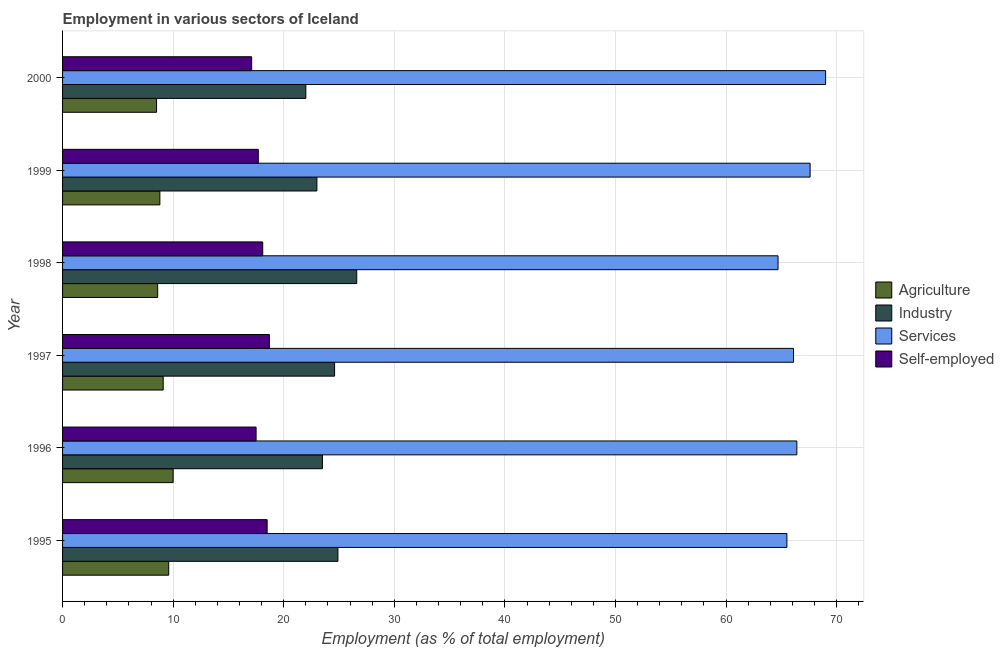Are the number of bars per tick equal to the number of legend labels?
Your response must be concise. Yes. What is the percentage of self employed workers in 2000?
Ensure brevity in your answer.  17.1. Across all years, what is the maximum percentage of workers in industry?
Your response must be concise. 26.6. Across all years, what is the minimum percentage of self employed workers?
Offer a terse response. 17.1. In which year was the percentage of workers in services minimum?
Ensure brevity in your answer.  1998. What is the total percentage of workers in agriculture in the graph?
Give a very brief answer. 54.6. What is the difference between the percentage of workers in services in 1996 and that in 1998?
Offer a terse response. 1.7. What is the difference between the percentage of workers in services in 1995 and the percentage of workers in agriculture in 1996?
Make the answer very short. 55.5. What is the average percentage of workers in services per year?
Provide a short and direct response. 66.55. Is the difference between the percentage of workers in industry in 1996 and 1999 greater than the difference between the percentage of workers in services in 1996 and 1999?
Offer a very short reply. Yes. What is the difference between the highest and the lowest percentage of workers in services?
Make the answer very short. 4.3. In how many years, is the percentage of workers in industry greater than the average percentage of workers in industry taken over all years?
Keep it short and to the point. 3. Is the sum of the percentage of self employed workers in 1996 and 1999 greater than the maximum percentage of workers in agriculture across all years?
Your answer should be compact. Yes. Is it the case that in every year, the sum of the percentage of workers in services and percentage of workers in industry is greater than the sum of percentage of self employed workers and percentage of workers in agriculture?
Offer a very short reply. No. What does the 1st bar from the top in 1997 represents?
Your answer should be very brief. Self-employed. What does the 3rd bar from the bottom in 1998 represents?
Your response must be concise. Services. Is it the case that in every year, the sum of the percentage of workers in agriculture and percentage of workers in industry is greater than the percentage of workers in services?
Your response must be concise. No. Are all the bars in the graph horizontal?
Give a very brief answer. Yes. How many years are there in the graph?
Your answer should be compact. 6. Are the values on the major ticks of X-axis written in scientific E-notation?
Offer a terse response. No. Does the graph contain any zero values?
Provide a succinct answer. No. How many legend labels are there?
Keep it short and to the point. 4. How are the legend labels stacked?
Make the answer very short. Vertical. What is the title of the graph?
Make the answer very short. Employment in various sectors of Iceland. What is the label or title of the X-axis?
Offer a terse response. Employment (as % of total employment). What is the Employment (as % of total employment) of Agriculture in 1995?
Your answer should be very brief. 9.6. What is the Employment (as % of total employment) of Industry in 1995?
Provide a succinct answer. 24.9. What is the Employment (as % of total employment) of Services in 1995?
Give a very brief answer. 65.5. What is the Employment (as % of total employment) of Self-employed in 1995?
Provide a short and direct response. 18.5. What is the Employment (as % of total employment) in Agriculture in 1996?
Your response must be concise. 10. What is the Employment (as % of total employment) of Services in 1996?
Offer a very short reply. 66.4. What is the Employment (as % of total employment) in Self-employed in 1996?
Your response must be concise. 17.5. What is the Employment (as % of total employment) of Agriculture in 1997?
Your answer should be very brief. 9.1. What is the Employment (as % of total employment) of Industry in 1997?
Offer a very short reply. 24.6. What is the Employment (as % of total employment) of Services in 1997?
Keep it short and to the point. 66.1. What is the Employment (as % of total employment) in Self-employed in 1997?
Your answer should be very brief. 18.7. What is the Employment (as % of total employment) in Agriculture in 1998?
Offer a terse response. 8.6. What is the Employment (as % of total employment) in Industry in 1998?
Provide a short and direct response. 26.6. What is the Employment (as % of total employment) in Services in 1998?
Keep it short and to the point. 64.7. What is the Employment (as % of total employment) of Self-employed in 1998?
Make the answer very short. 18.1. What is the Employment (as % of total employment) of Agriculture in 1999?
Keep it short and to the point. 8.8. What is the Employment (as % of total employment) of Industry in 1999?
Make the answer very short. 23. What is the Employment (as % of total employment) in Services in 1999?
Your answer should be compact. 67.6. What is the Employment (as % of total employment) in Self-employed in 1999?
Make the answer very short. 17.7. What is the Employment (as % of total employment) of Services in 2000?
Make the answer very short. 69. What is the Employment (as % of total employment) of Self-employed in 2000?
Ensure brevity in your answer.  17.1. Across all years, what is the maximum Employment (as % of total employment) of Industry?
Your answer should be very brief. 26.6. Across all years, what is the maximum Employment (as % of total employment) in Self-employed?
Make the answer very short. 18.7. Across all years, what is the minimum Employment (as % of total employment) in Agriculture?
Ensure brevity in your answer.  8.5. Across all years, what is the minimum Employment (as % of total employment) of Services?
Keep it short and to the point. 64.7. Across all years, what is the minimum Employment (as % of total employment) of Self-employed?
Your response must be concise. 17.1. What is the total Employment (as % of total employment) of Agriculture in the graph?
Give a very brief answer. 54.6. What is the total Employment (as % of total employment) of Industry in the graph?
Ensure brevity in your answer.  144.6. What is the total Employment (as % of total employment) of Services in the graph?
Ensure brevity in your answer.  399.3. What is the total Employment (as % of total employment) in Self-employed in the graph?
Your answer should be compact. 107.6. What is the difference between the Employment (as % of total employment) of Services in 1995 and that in 1996?
Provide a short and direct response. -0.9. What is the difference between the Employment (as % of total employment) in Industry in 1995 and that in 1997?
Your answer should be compact. 0.3. What is the difference between the Employment (as % of total employment) in Services in 1995 and that in 1997?
Give a very brief answer. -0.6. What is the difference between the Employment (as % of total employment) of Industry in 1995 and that in 1998?
Give a very brief answer. -1.7. What is the difference between the Employment (as % of total employment) in Services in 1995 and that in 1998?
Make the answer very short. 0.8. What is the difference between the Employment (as % of total employment) of Agriculture in 1995 and that in 1999?
Offer a terse response. 0.8. What is the difference between the Employment (as % of total employment) in Industry in 1995 and that in 1999?
Your answer should be compact. 1.9. What is the difference between the Employment (as % of total employment) in Agriculture in 1995 and that in 2000?
Make the answer very short. 1.1. What is the difference between the Employment (as % of total employment) of Industry in 1995 and that in 2000?
Give a very brief answer. 2.9. What is the difference between the Employment (as % of total employment) of Self-employed in 1995 and that in 2000?
Your response must be concise. 1.4. What is the difference between the Employment (as % of total employment) of Agriculture in 1996 and that in 1997?
Offer a very short reply. 0.9. What is the difference between the Employment (as % of total employment) of Industry in 1996 and that in 1997?
Your answer should be very brief. -1.1. What is the difference between the Employment (as % of total employment) of Self-employed in 1996 and that in 1997?
Provide a succinct answer. -1.2. What is the difference between the Employment (as % of total employment) of Agriculture in 1996 and that in 1998?
Your answer should be compact. 1.4. What is the difference between the Employment (as % of total employment) in Self-employed in 1996 and that in 1998?
Offer a terse response. -0.6. What is the difference between the Employment (as % of total employment) in Agriculture in 1996 and that in 1999?
Your response must be concise. 1.2. What is the difference between the Employment (as % of total employment) in Industry in 1996 and that in 1999?
Your response must be concise. 0.5. What is the difference between the Employment (as % of total employment) in Self-employed in 1996 and that in 1999?
Give a very brief answer. -0.2. What is the difference between the Employment (as % of total employment) of Services in 1996 and that in 2000?
Your answer should be very brief. -2.6. What is the difference between the Employment (as % of total employment) in Agriculture in 1997 and that in 1998?
Make the answer very short. 0.5. What is the difference between the Employment (as % of total employment) of Industry in 1997 and that in 1998?
Give a very brief answer. -2. What is the difference between the Employment (as % of total employment) of Agriculture in 1997 and that in 1999?
Give a very brief answer. 0.3. What is the difference between the Employment (as % of total employment) in Industry in 1997 and that in 1999?
Ensure brevity in your answer.  1.6. What is the difference between the Employment (as % of total employment) of Self-employed in 1997 and that in 1999?
Your answer should be compact. 1. What is the difference between the Employment (as % of total employment) in Agriculture in 1997 and that in 2000?
Ensure brevity in your answer.  0.6. What is the difference between the Employment (as % of total employment) in Industry in 1997 and that in 2000?
Give a very brief answer. 2.6. What is the difference between the Employment (as % of total employment) of Agriculture in 1998 and that in 1999?
Your answer should be compact. -0.2. What is the difference between the Employment (as % of total employment) in Services in 1998 and that in 1999?
Provide a short and direct response. -2.9. What is the difference between the Employment (as % of total employment) of Self-employed in 1998 and that in 1999?
Give a very brief answer. 0.4. What is the difference between the Employment (as % of total employment) of Industry in 1999 and that in 2000?
Your answer should be compact. 1. What is the difference between the Employment (as % of total employment) in Services in 1999 and that in 2000?
Keep it short and to the point. -1.4. What is the difference between the Employment (as % of total employment) in Self-employed in 1999 and that in 2000?
Your answer should be compact. 0.6. What is the difference between the Employment (as % of total employment) in Agriculture in 1995 and the Employment (as % of total employment) in Services in 1996?
Provide a succinct answer. -56.8. What is the difference between the Employment (as % of total employment) in Industry in 1995 and the Employment (as % of total employment) in Services in 1996?
Give a very brief answer. -41.5. What is the difference between the Employment (as % of total employment) of Industry in 1995 and the Employment (as % of total employment) of Self-employed in 1996?
Keep it short and to the point. 7.4. What is the difference between the Employment (as % of total employment) in Agriculture in 1995 and the Employment (as % of total employment) in Industry in 1997?
Your answer should be very brief. -15. What is the difference between the Employment (as % of total employment) in Agriculture in 1995 and the Employment (as % of total employment) in Services in 1997?
Keep it short and to the point. -56.5. What is the difference between the Employment (as % of total employment) of Industry in 1995 and the Employment (as % of total employment) of Services in 1997?
Offer a terse response. -41.2. What is the difference between the Employment (as % of total employment) in Industry in 1995 and the Employment (as % of total employment) in Self-employed in 1997?
Your response must be concise. 6.2. What is the difference between the Employment (as % of total employment) in Services in 1995 and the Employment (as % of total employment) in Self-employed in 1997?
Make the answer very short. 46.8. What is the difference between the Employment (as % of total employment) in Agriculture in 1995 and the Employment (as % of total employment) in Industry in 1998?
Provide a succinct answer. -17. What is the difference between the Employment (as % of total employment) of Agriculture in 1995 and the Employment (as % of total employment) of Services in 1998?
Offer a very short reply. -55.1. What is the difference between the Employment (as % of total employment) of Industry in 1995 and the Employment (as % of total employment) of Services in 1998?
Provide a short and direct response. -39.8. What is the difference between the Employment (as % of total employment) of Services in 1995 and the Employment (as % of total employment) of Self-employed in 1998?
Ensure brevity in your answer.  47.4. What is the difference between the Employment (as % of total employment) of Agriculture in 1995 and the Employment (as % of total employment) of Industry in 1999?
Your answer should be compact. -13.4. What is the difference between the Employment (as % of total employment) in Agriculture in 1995 and the Employment (as % of total employment) in Services in 1999?
Provide a short and direct response. -58. What is the difference between the Employment (as % of total employment) in Agriculture in 1995 and the Employment (as % of total employment) in Self-employed in 1999?
Your answer should be very brief. -8.1. What is the difference between the Employment (as % of total employment) in Industry in 1995 and the Employment (as % of total employment) in Services in 1999?
Your response must be concise. -42.7. What is the difference between the Employment (as % of total employment) of Industry in 1995 and the Employment (as % of total employment) of Self-employed in 1999?
Make the answer very short. 7.2. What is the difference between the Employment (as % of total employment) of Services in 1995 and the Employment (as % of total employment) of Self-employed in 1999?
Keep it short and to the point. 47.8. What is the difference between the Employment (as % of total employment) of Agriculture in 1995 and the Employment (as % of total employment) of Services in 2000?
Offer a very short reply. -59.4. What is the difference between the Employment (as % of total employment) in Industry in 1995 and the Employment (as % of total employment) in Services in 2000?
Give a very brief answer. -44.1. What is the difference between the Employment (as % of total employment) in Industry in 1995 and the Employment (as % of total employment) in Self-employed in 2000?
Your answer should be very brief. 7.8. What is the difference between the Employment (as % of total employment) of Services in 1995 and the Employment (as % of total employment) of Self-employed in 2000?
Keep it short and to the point. 48.4. What is the difference between the Employment (as % of total employment) in Agriculture in 1996 and the Employment (as % of total employment) in Industry in 1997?
Keep it short and to the point. -14.6. What is the difference between the Employment (as % of total employment) of Agriculture in 1996 and the Employment (as % of total employment) of Services in 1997?
Give a very brief answer. -56.1. What is the difference between the Employment (as % of total employment) of Agriculture in 1996 and the Employment (as % of total employment) of Self-employed in 1997?
Offer a very short reply. -8.7. What is the difference between the Employment (as % of total employment) of Industry in 1996 and the Employment (as % of total employment) of Services in 1997?
Your response must be concise. -42.6. What is the difference between the Employment (as % of total employment) of Industry in 1996 and the Employment (as % of total employment) of Self-employed in 1997?
Ensure brevity in your answer.  4.8. What is the difference between the Employment (as % of total employment) of Services in 1996 and the Employment (as % of total employment) of Self-employed in 1997?
Keep it short and to the point. 47.7. What is the difference between the Employment (as % of total employment) of Agriculture in 1996 and the Employment (as % of total employment) of Industry in 1998?
Your answer should be compact. -16.6. What is the difference between the Employment (as % of total employment) of Agriculture in 1996 and the Employment (as % of total employment) of Services in 1998?
Offer a very short reply. -54.7. What is the difference between the Employment (as % of total employment) in Agriculture in 1996 and the Employment (as % of total employment) in Self-employed in 1998?
Offer a very short reply. -8.1. What is the difference between the Employment (as % of total employment) of Industry in 1996 and the Employment (as % of total employment) of Services in 1998?
Your answer should be very brief. -41.2. What is the difference between the Employment (as % of total employment) in Services in 1996 and the Employment (as % of total employment) in Self-employed in 1998?
Your response must be concise. 48.3. What is the difference between the Employment (as % of total employment) of Agriculture in 1996 and the Employment (as % of total employment) of Services in 1999?
Provide a short and direct response. -57.6. What is the difference between the Employment (as % of total employment) in Agriculture in 1996 and the Employment (as % of total employment) in Self-employed in 1999?
Provide a succinct answer. -7.7. What is the difference between the Employment (as % of total employment) of Industry in 1996 and the Employment (as % of total employment) of Services in 1999?
Provide a succinct answer. -44.1. What is the difference between the Employment (as % of total employment) in Services in 1996 and the Employment (as % of total employment) in Self-employed in 1999?
Offer a very short reply. 48.7. What is the difference between the Employment (as % of total employment) in Agriculture in 1996 and the Employment (as % of total employment) in Industry in 2000?
Provide a short and direct response. -12. What is the difference between the Employment (as % of total employment) of Agriculture in 1996 and the Employment (as % of total employment) of Services in 2000?
Give a very brief answer. -59. What is the difference between the Employment (as % of total employment) in Agriculture in 1996 and the Employment (as % of total employment) in Self-employed in 2000?
Give a very brief answer. -7.1. What is the difference between the Employment (as % of total employment) in Industry in 1996 and the Employment (as % of total employment) in Services in 2000?
Provide a short and direct response. -45.5. What is the difference between the Employment (as % of total employment) in Industry in 1996 and the Employment (as % of total employment) in Self-employed in 2000?
Offer a terse response. 6.4. What is the difference between the Employment (as % of total employment) of Services in 1996 and the Employment (as % of total employment) of Self-employed in 2000?
Provide a short and direct response. 49.3. What is the difference between the Employment (as % of total employment) of Agriculture in 1997 and the Employment (as % of total employment) of Industry in 1998?
Your response must be concise. -17.5. What is the difference between the Employment (as % of total employment) of Agriculture in 1997 and the Employment (as % of total employment) of Services in 1998?
Your response must be concise. -55.6. What is the difference between the Employment (as % of total employment) of Agriculture in 1997 and the Employment (as % of total employment) of Self-employed in 1998?
Provide a succinct answer. -9. What is the difference between the Employment (as % of total employment) of Industry in 1997 and the Employment (as % of total employment) of Services in 1998?
Offer a terse response. -40.1. What is the difference between the Employment (as % of total employment) in Agriculture in 1997 and the Employment (as % of total employment) in Industry in 1999?
Your response must be concise. -13.9. What is the difference between the Employment (as % of total employment) in Agriculture in 1997 and the Employment (as % of total employment) in Services in 1999?
Your response must be concise. -58.5. What is the difference between the Employment (as % of total employment) of Industry in 1997 and the Employment (as % of total employment) of Services in 1999?
Ensure brevity in your answer.  -43. What is the difference between the Employment (as % of total employment) of Services in 1997 and the Employment (as % of total employment) of Self-employed in 1999?
Make the answer very short. 48.4. What is the difference between the Employment (as % of total employment) in Agriculture in 1997 and the Employment (as % of total employment) in Industry in 2000?
Your response must be concise. -12.9. What is the difference between the Employment (as % of total employment) in Agriculture in 1997 and the Employment (as % of total employment) in Services in 2000?
Your answer should be very brief. -59.9. What is the difference between the Employment (as % of total employment) in Agriculture in 1997 and the Employment (as % of total employment) in Self-employed in 2000?
Your response must be concise. -8. What is the difference between the Employment (as % of total employment) of Industry in 1997 and the Employment (as % of total employment) of Services in 2000?
Provide a succinct answer. -44.4. What is the difference between the Employment (as % of total employment) in Industry in 1997 and the Employment (as % of total employment) in Self-employed in 2000?
Keep it short and to the point. 7.5. What is the difference between the Employment (as % of total employment) of Services in 1997 and the Employment (as % of total employment) of Self-employed in 2000?
Make the answer very short. 49. What is the difference between the Employment (as % of total employment) in Agriculture in 1998 and the Employment (as % of total employment) in Industry in 1999?
Ensure brevity in your answer.  -14.4. What is the difference between the Employment (as % of total employment) of Agriculture in 1998 and the Employment (as % of total employment) of Services in 1999?
Keep it short and to the point. -59. What is the difference between the Employment (as % of total employment) of Agriculture in 1998 and the Employment (as % of total employment) of Self-employed in 1999?
Your answer should be very brief. -9.1. What is the difference between the Employment (as % of total employment) in Industry in 1998 and the Employment (as % of total employment) in Services in 1999?
Ensure brevity in your answer.  -41. What is the difference between the Employment (as % of total employment) of Services in 1998 and the Employment (as % of total employment) of Self-employed in 1999?
Provide a succinct answer. 47. What is the difference between the Employment (as % of total employment) in Agriculture in 1998 and the Employment (as % of total employment) in Industry in 2000?
Give a very brief answer. -13.4. What is the difference between the Employment (as % of total employment) of Agriculture in 1998 and the Employment (as % of total employment) of Services in 2000?
Give a very brief answer. -60.4. What is the difference between the Employment (as % of total employment) of Industry in 1998 and the Employment (as % of total employment) of Services in 2000?
Keep it short and to the point. -42.4. What is the difference between the Employment (as % of total employment) in Services in 1998 and the Employment (as % of total employment) in Self-employed in 2000?
Provide a short and direct response. 47.6. What is the difference between the Employment (as % of total employment) of Agriculture in 1999 and the Employment (as % of total employment) of Industry in 2000?
Keep it short and to the point. -13.2. What is the difference between the Employment (as % of total employment) of Agriculture in 1999 and the Employment (as % of total employment) of Services in 2000?
Provide a succinct answer. -60.2. What is the difference between the Employment (as % of total employment) in Agriculture in 1999 and the Employment (as % of total employment) in Self-employed in 2000?
Ensure brevity in your answer.  -8.3. What is the difference between the Employment (as % of total employment) in Industry in 1999 and the Employment (as % of total employment) in Services in 2000?
Give a very brief answer. -46. What is the difference between the Employment (as % of total employment) in Industry in 1999 and the Employment (as % of total employment) in Self-employed in 2000?
Provide a short and direct response. 5.9. What is the difference between the Employment (as % of total employment) of Services in 1999 and the Employment (as % of total employment) of Self-employed in 2000?
Provide a succinct answer. 50.5. What is the average Employment (as % of total employment) in Industry per year?
Keep it short and to the point. 24.1. What is the average Employment (as % of total employment) of Services per year?
Offer a terse response. 66.55. What is the average Employment (as % of total employment) of Self-employed per year?
Your answer should be very brief. 17.93. In the year 1995, what is the difference between the Employment (as % of total employment) in Agriculture and Employment (as % of total employment) in Industry?
Give a very brief answer. -15.3. In the year 1995, what is the difference between the Employment (as % of total employment) of Agriculture and Employment (as % of total employment) of Services?
Offer a very short reply. -55.9. In the year 1995, what is the difference between the Employment (as % of total employment) in Industry and Employment (as % of total employment) in Services?
Your answer should be very brief. -40.6. In the year 1996, what is the difference between the Employment (as % of total employment) in Agriculture and Employment (as % of total employment) in Industry?
Your response must be concise. -13.5. In the year 1996, what is the difference between the Employment (as % of total employment) in Agriculture and Employment (as % of total employment) in Services?
Provide a short and direct response. -56.4. In the year 1996, what is the difference between the Employment (as % of total employment) of Agriculture and Employment (as % of total employment) of Self-employed?
Provide a succinct answer. -7.5. In the year 1996, what is the difference between the Employment (as % of total employment) of Industry and Employment (as % of total employment) of Services?
Ensure brevity in your answer.  -42.9. In the year 1996, what is the difference between the Employment (as % of total employment) of Industry and Employment (as % of total employment) of Self-employed?
Offer a very short reply. 6. In the year 1996, what is the difference between the Employment (as % of total employment) in Services and Employment (as % of total employment) in Self-employed?
Offer a terse response. 48.9. In the year 1997, what is the difference between the Employment (as % of total employment) of Agriculture and Employment (as % of total employment) of Industry?
Offer a very short reply. -15.5. In the year 1997, what is the difference between the Employment (as % of total employment) of Agriculture and Employment (as % of total employment) of Services?
Keep it short and to the point. -57. In the year 1997, what is the difference between the Employment (as % of total employment) in Industry and Employment (as % of total employment) in Services?
Make the answer very short. -41.5. In the year 1997, what is the difference between the Employment (as % of total employment) of Services and Employment (as % of total employment) of Self-employed?
Your answer should be very brief. 47.4. In the year 1998, what is the difference between the Employment (as % of total employment) of Agriculture and Employment (as % of total employment) of Industry?
Give a very brief answer. -18. In the year 1998, what is the difference between the Employment (as % of total employment) of Agriculture and Employment (as % of total employment) of Services?
Make the answer very short. -56.1. In the year 1998, what is the difference between the Employment (as % of total employment) in Agriculture and Employment (as % of total employment) in Self-employed?
Provide a succinct answer. -9.5. In the year 1998, what is the difference between the Employment (as % of total employment) of Industry and Employment (as % of total employment) of Services?
Ensure brevity in your answer.  -38.1. In the year 1998, what is the difference between the Employment (as % of total employment) of Industry and Employment (as % of total employment) of Self-employed?
Your answer should be compact. 8.5. In the year 1998, what is the difference between the Employment (as % of total employment) in Services and Employment (as % of total employment) in Self-employed?
Your response must be concise. 46.6. In the year 1999, what is the difference between the Employment (as % of total employment) of Agriculture and Employment (as % of total employment) of Industry?
Offer a terse response. -14.2. In the year 1999, what is the difference between the Employment (as % of total employment) of Agriculture and Employment (as % of total employment) of Services?
Your answer should be compact. -58.8. In the year 1999, what is the difference between the Employment (as % of total employment) of Agriculture and Employment (as % of total employment) of Self-employed?
Keep it short and to the point. -8.9. In the year 1999, what is the difference between the Employment (as % of total employment) in Industry and Employment (as % of total employment) in Services?
Your answer should be compact. -44.6. In the year 1999, what is the difference between the Employment (as % of total employment) of Industry and Employment (as % of total employment) of Self-employed?
Provide a short and direct response. 5.3. In the year 1999, what is the difference between the Employment (as % of total employment) of Services and Employment (as % of total employment) of Self-employed?
Your answer should be compact. 49.9. In the year 2000, what is the difference between the Employment (as % of total employment) in Agriculture and Employment (as % of total employment) in Industry?
Keep it short and to the point. -13.5. In the year 2000, what is the difference between the Employment (as % of total employment) in Agriculture and Employment (as % of total employment) in Services?
Your answer should be very brief. -60.5. In the year 2000, what is the difference between the Employment (as % of total employment) in Agriculture and Employment (as % of total employment) in Self-employed?
Your answer should be compact. -8.6. In the year 2000, what is the difference between the Employment (as % of total employment) of Industry and Employment (as % of total employment) of Services?
Your answer should be compact. -47. In the year 2000, what is the difference between the Employment (as % of total employment) in Services and Employment (as % of total employment) in Self-employed?
Ensure brevity in your answer.  51.9. What is the ratio of the Employment (as % of total employment) in Industry in 1995 to that in 1996?
Offer a terse response. 1.06. What is the ratio of the Employment (as % of total employment) of Services in 1995 to that in 1996?
Provide a short and direct response. 0.99. What is the ratio of the Employment (as % of total employment) of Self-employed in 1995 to that in 1996?
Make the answer very short. 1.06. What is the ratio of the Employment (as % of total employment) of Agriculture in 1995 to that in 1997?
Your response must be concise. 1.05. What is the ratio of the Employment (as % of total employment) of Industry in 1995 to that in 1997?
Give a very brief answer. 1.01. What is the ratio of the Employment (as % of total employment) in Services in 1995 to that in 1997?
Give a very brief answer. 0.99. What is the ratio of the Employment (as % of total employment) in Self-employed in 1995 to that in 1997?
Provide a short and direct response. 0.99. What is the ratio of the Employment (as % of total employment) in Agriculture in 1995 to that in 1998?
Your response must be concise. 1.12. What is the ratio of the Employment (as % of total employment) of Industry in 1995 to that in 1998?
Make the answer very short. 0.94. What is the ratio of the Employment (as % of total employment) of Services in 1995 to that in 1998?
Your response must be concise. 1.01. What is the ratio of the Employment (as % of total employment) of Self-employed in 1995 to that in 1998?
Your answer should be very brief. 1.02. What is the ratio of the Employment (as % of total employment) in Industry in 1995 to that in 1999?
Your answer should be compact. 1.08. What is the ratio of the Employment (as % of total employment) in Services in 1995 to that in 1999?
Your response must be concise. 0.97. What is the ratio of the Employment (as % of total employment) in Self-employed in 1995 to that in 1999?
Your answer should be very brief. 1.05. What is the ratio of the Employment (as % of total employment) of Agriculture in 1995 to that in 2000?
Your response must be concise. 1.13. What is the ratio of the Employment (as % of total employment) in Industry in 1995 to that in 2000?
Make the answer very short. 1.13. What is the ratio of the Employment (as % of total employment) of Services in 1995 to that in 2000?
Your answer should be very brief. 0.95. What is the ratio of the Employment (as % of total employment) in Self-employed in 1995 to that in 2000?
Offer a terse response. 1.08. What is the ratio of the Employment (as % of total employment) of Agriculture in 1996 to that in 1997?
Offer a very short reply. 1.1. What is the ratio of the Employment (as % of total employment) in Industry in 1996 to that in 1997?
Offer a very short reply. 0.96. What is the ratio of the Employment (as % of total employment) of Self-employed in 1996 to that in 1997?
Provide a short and direct response. 0.94. What is the ratio of the Employment (as % of total employment) in Agriculture in 1996 to that in 1998?
Make the answer very short. 1.16. What is the ratio of the Employment (as % of total employment) of Industry in 1996 to that in 1998?
Ensure brevity in your answer.  0.88. What is the ratio of the Employment (as % of total employment) of Services in 1996 to that in 1998?
Your answer should be very brief. 1.03. What is the ratio of the Employment (as % of total employment) in Self-employed in 1996 to that in 1998?
Your response must be concise. 0.97. What is the ratio of the Employment (as % of total employment) in Agriculture in 1996 to that in 1999?
Provide a short and direct response. 1.14. What is the ratio of the Employment (as % of total employment) of Industry in 1996 to that in 1999?
Provide a succinct answer. 1.02. What is the ratio of the Employment (as % of total employment) in Services in 1996 to that in 1999?
Ensure brevity in your answer.  0.98. What is the ratio of the Employment (as % of total employment) of Self-employed in 1996 to that in 1999?
Provide a succinct answer. 0.99. What is the ratio of the Employment (as % of total employment) in Agriculture in 1996 to that in 2000?
Provide a short and direct response. 1.18. What is the ratio of the Employment (as % of total employment) in Industry in 1996 to that in 2000?
Offer a terse response. 1.07. What is the ratio of the Employment (as % of total employment) of Services in 1996 to that in 2000?
Your answer should be very brief. 0.96. What is the ratio of the Employment (as % of total employment) in Self-employed in 1996 to that in 2000?
Give a very brief answer. 1.02. What is the ratio of the Employment (as % of total employment) of Agriculture in 1997 to that in 1998?
Offer a very short reply. 1.06. What is the ratio of the Employment (as % of total employment) of Industry in 1997 to that in 1998?
Ensure brevity in your answer.  0.92. What is the ratio of the Employment (as % of total employment) in Services in 1997 to that in 1998?
Your response must be concise. 1.02. What is the ratio of the Employment (as % of total employment) in Self-employed in 1997 to that in 1998?
Your answer should be compact. 1.03. What is the ratio of the Employment (as % of total employment) in Agriculture in 1997 to that in 1999?
Provide a succinct answer. 1.03. What is the ratio of the Employment (as % of total employment) in Industry in 1997 to that in 1999?
Offer a terse response. 1.07. What is the ratio of the Employment (as % of total employment) of Services in 1997 to that in 1999?
Your answer should be compact. 0.98. What is the ratio of the Employment (as % of total employment) in Self-employed in 1997 to that in 1999?
Keep it short and to the point. 1.06. What is the ratio of the Employment (as % of total employment) in Agriculture in 1997 to that in 2000?
Ensure brevity in your answer.  1.07. What is the ratio of the Employment (as % of total employment) of Industry in 1997 to that in 2000?
Your response must be concise. 1.12. What is the ratio of the Employment (as % of total employment) of Services in 1997 to that in 2000?
Ensure brevity in your answer.  0.96. What is the ratio of the Employment (as % of total employment) of Self-employed in 1997 to that in 2000?
Keep it short and to the point. 1.09. What is the ratio of the Employment (as % of total employment) in Agriculture in 1998 to that in 1999?
Offer a very short reply. 0.98. What is the ratio of the Employment (as % of total employment) in Industry in 1998 to that in 1999?
Keep it short and to the point. 1.16. What is the ratio of the Employment (as % of total employment) of Services in 1998 to that in 1999?
Your answer should be compact. 0.96. What is the ratio of the Employment (as % of total employment) of Self-employed in 1998 to that in 1999?
Ensure brevity in your answer.  1.02. What is the ratio of the Employment (as % of total employment) of Agriculture in 1998 to that in 2000?
Provide a short and direct response. 1.01. What is the ratio of the Employment (as % of total employment) of Industry in 1998 to that in 2000?
Offer a very short reply. 1.21. What is the ratio of the Employment (as % of total employment) in Services in 1998 to that in 2000?
Keep it short and to the point. 0.94. What is the ratio of the Employment (as % of total employment) of Self-employed in 1998 to that in 2000?
Make the answer very short. 1.06. What is the ratio of the Employment (as % of total employment) of Agriculture in 1999 to that in 2000?
Make the answer very short. 1.04. What is the ratio of the Employment (as % of total employment) of Industry in 1999 to that in 2000?
Make the answer very short. 1.05. What is the ratio of the Employment (as % of total employment) in Services in 1999 to that in 2000?
Keep it short and to the point. 0.98. What is the ratio of the Employment (as % of total employment) of Self-employed in 1999 to that in 2000?
Your response must be concise. 1.04. What is the difference between the highest and the lowest Employment (as % of total employment) in Agriculture?
Offer a terse response. 1.5. What is the difference between the highest and the lowest Employment (as % of total employment) of Industry?
Your answer should be very brief. 4.6. What is the difference between the highest and the lowest Employment (as % of total employment) of Services?
Ensure brevity in your answer.  4.3. 